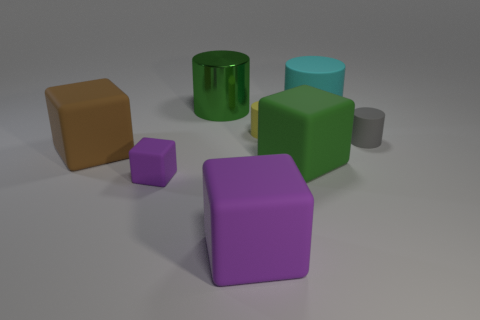Subtract all tiny yellow cylinders. How many cylinders are left? 3 Subtract all gray balls. How many purple cubes are left? 2 Subtract all green cubes. How many cubes are left? 3 Subtract 2 cylinders. How many cylinders are left? 2 Subtract all brown cylinders. Subtract all green blocks. How many cylinders are left? 4 Add 2 rubber objects. How many objects exist? 10 Add 5 large things. How many large things are left? 10 Add 1 small rubber cubes. How many small rubber cubes exist? 2 Subtract 0 blue balls. How many objects are left? 8 Subtract all matte blocks. Subtract all big cyan rubber cylinders. How many objects are left? 3 